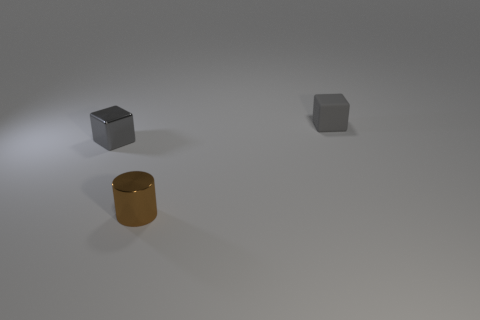Add 3 big objects. How many objects exist? 6 Subtract all cylinders. How many objects are left? 2 Add 3 gray cylinders. How many gray cylinders exist? 3 Subtract 0 purple cylinders. How many objects are left? 3 Subtract all cylinders. Subtract all small metallic things. How many objects are left? 0 Add 2 cylinders. How many cylinders are left? 3 